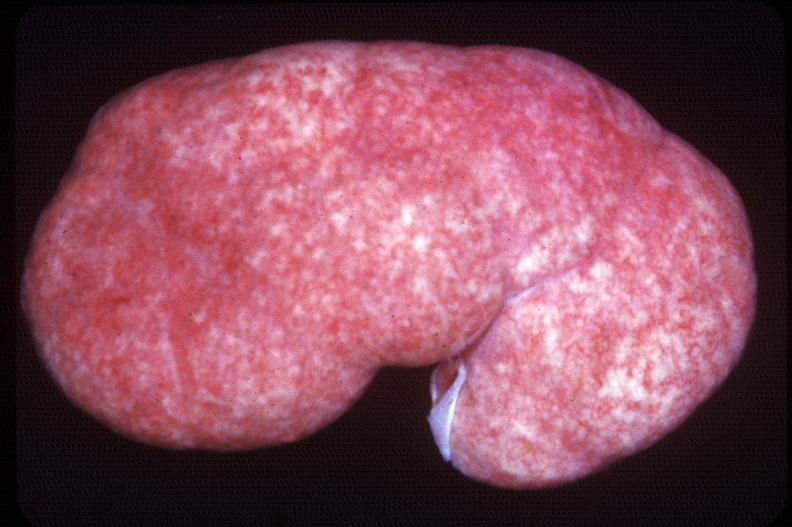where is this?
Answer the question using a single word or phrase. Urinary 